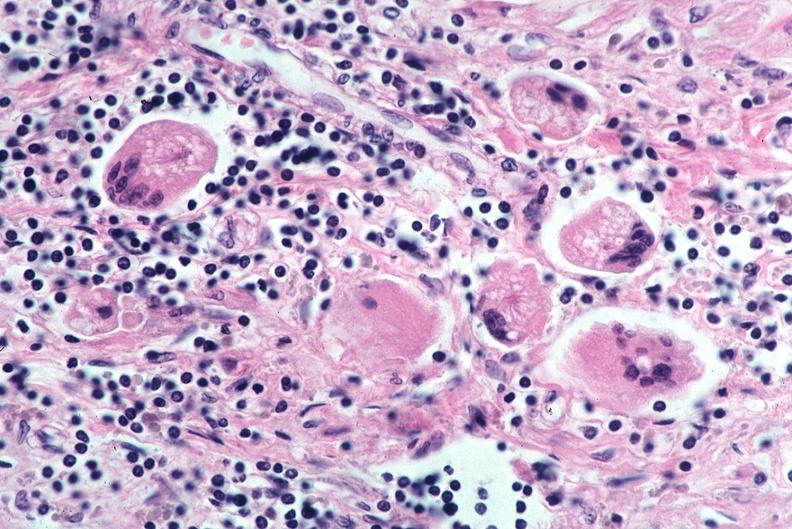what does this image show?
Answer the question using a single word or phrase. Lung 